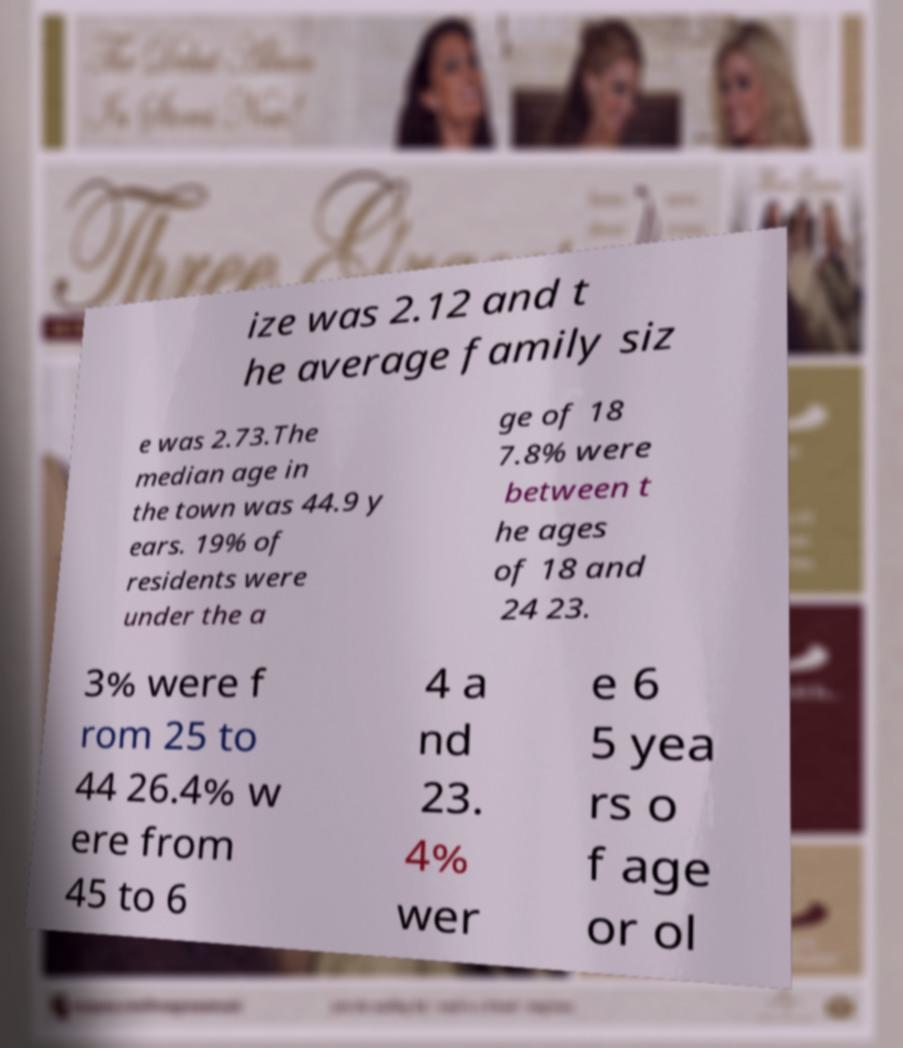Could you extract and type out the text from this image? ize was 2.12 and t he average family siz e was 2.73.The median age in the town was 44.9 y ears. 19% of residents were under the a ge of 18 7.8% were between t he ages of 18 and 24 23. 3% were f rom 25 to 44 26.4% w ere from 45 to 6 4 a nd 23. 4% wer e 6 5 yea rs o f age or ol 